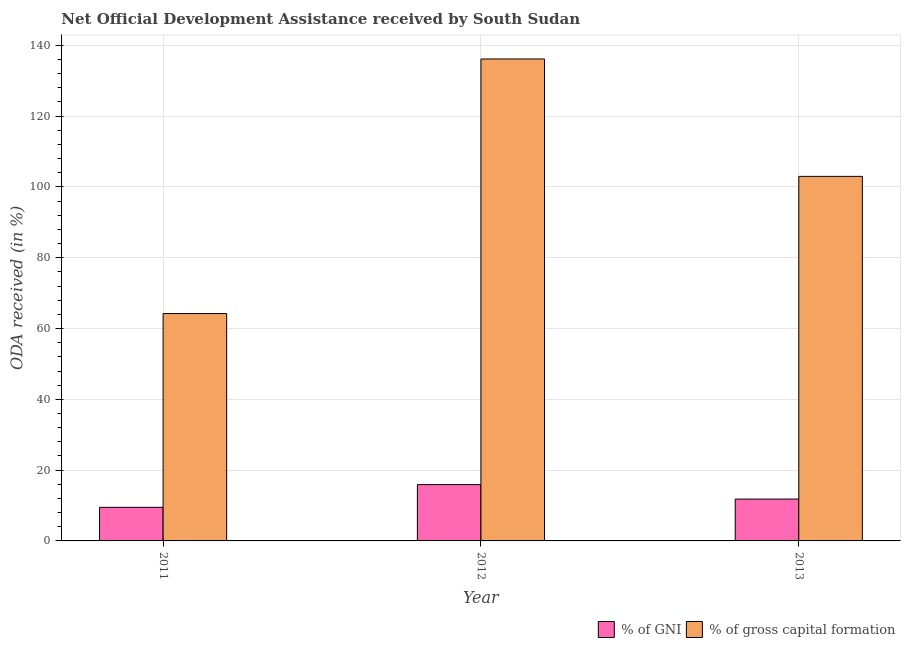How many different coloured bars are there?
Give a very brief answer. 2. How many groups of bars are there?
Ensure brevity in your answer.  3. Are the number of bars per tick equal to the number of legend labels?
Offer a terse response. Yes. How many bars are there on the 1st tick from the left?
Your answer should be very brief. 2. What is the label of the 3rd group of bars from the left?
Offer a terse response. 2013. What is the oda received as percentage of gni in 2011?
Your answer should be very brief. 9.49. Across all years, what is the maximum oda received as percentage of gross capital formation?
Give a very brief answer. 136.15. Across all years, what is the minimum oda received as percentage of gross capital formation?
Offer a terse response. 64.23. In which year was the oda received as percentage of gni minimum?
Make the answer very short. 2011. What is the total oda received as percentage of gross capital formation in the graph?
Give a very brief answer. 303.38. What is the difference between the oda received as percentage of gni in 2011 and that in 2013?
Your answer should be very brief. -2.34. What is the difference between the oda received as percentage of gni in 2012 and the oda received as percentage of gross capital formation in 2013?
Keep it short and to the point. 4.08. What is the average oda received as percentage of gross capital formation per year?
Provide a succinct answer. 101.13. In the year 2011, what is the difference between the oda received as percentage of gni and oda received as percentage of gross capital formation?
Offer a very short reply. 0. What is the ratio of the oda received as percentage of gni in 2011 to that in 2013?
Ensure brevity in your answer.  0.8. Is the oda received as percentage of gross capital formation in 2011 less than that in 2012?
Give a very brief answer. Yes. Is the difference between the oda received as percentage of gni in 2011 and 2012 greater than the difference between the oda received as percentage of gross capital formation in 2011 and 2012?
Offer a terse response. No. What is the difference between the highest and the second highest oda received as percentage of gni?
Provide a succinct answer. 4.08. What is the difference between the highest and the lowest oda received as percentage of gross capital formation?
Your response must be concise. 71.92. What does the 2nd bar from the left in 2013 represents?
Provide a succinct answer. % of gross capital formation. What does the 2nd bar from the right in 2012 represents?
Your response must be concise. % of GNI. How many bars are there?
Keep it short and to the point. 6. Are all the bars in the graph horizontal?
Ensure brevity in your answer.  No. How many years are there in the graph?
Give a very brief answer. 3. What is the difference between two consecutive major ticks on the Y-axis?
Your answer should be very brief. 20. Are the values on the major ticks of Y-axis written in scientific E-notation?
Provide a succinct answer. No. Does the graph contain any zero values?
Your response must be concise. No. Does the graph contain grids?
Your response must be concise. Yes. How many legend labels are there?
Your answer should be compact. 2. How are the legend labels stacked?
Give a very brief answer. Horizontal. What is the title of the graph?
Offer a very short reply. Net Official Development Assistance received by South Sudan. Does "Tetanus" appear as one of the legend labels in the graph?
Ensure brevity in your answer.  No. What is the label or title of the X-axis?
Your answer should be compact. Year. What is the label or title of the Y-axis?
Offer a very short reply. ODA received (in %). What is the ODA received (in %) in % of GNI in 2011?
Offer a very short reply. 9.49. What is the ODA received (in %) in % of gross capital formation in 2011?
Keep it short and to the point. 64.23. What is the ODA received (in %) of % of GNI in 2012?
Give a very brief answer. 15.9. What is the ODA received (in %) in % of gross capital formation in 2012?
Ensure brevity in your answer.  136.15. What is the ODA received (in %) in % of GNI in 2013?
Provide a succinct answer. 11.82. What is the ODA received (in %) of % of gross capital formation in 2013?
Your answer should be very brief. 102.99. Across all years, what is the maximum ODA received (in %) of % of GNI?
Give a very brief answer. 15.9. Across all years, what is the maximum ODA received (in %) in % of gross capital formation?
Provide a succinct answer. 136.15. Across all years, what is the minimum ODA received (in %) in % of GNI?
Offer a very short reply. 9.49. Across all years, what is the minimum ODA received (in %) of % of gross capital formation?
Your answer should be compact. 64.23. What is the total ODA received (in %) in % of GNI in the graph?
Provide a succinct answer. 37.21. What is the total ODA received (in %) of % of gross capital formation in the graph?
Make the answer very short. 303.38. What is the difference between the ODA received (in %) of % of GNI in 2011 and that in 2012?
Keep it short and to the point. -6.42. What is the difference between the ODA received (in %) in % of gross capital formation in 2011 and that in 2012?
Your answer should be compact. -71.92. What is the difference between the ODA received (in %) of % of GNI in 2011 and that in 2013?
Your answer should be very brief. -2.34. What is the difference between the ODA received (in %) in % of gross capital formation in 2011 and that in 2013?
Ensure brevity in your answer.  -38.76. What is the difference between the ODA received (in %) of % of GNI in 2012 and that in 2013?
Provide a succinct answer. 4.08. What is the difference between the ODA received (in %) of % of gross capital formation in 2012 and that in 2013?
Your response must be concise. 33.16. What is the difference between the ODA received (in %) in % of GNI in 2011 and the ODA received (in %) in % of gross capital formation in 2012?
Ensure brevity in your answer.  -126.67. What is the difference between the ODA received (in %) in % of GNI in 2011 and the ODA received (in %) in % of gross capital formation in 2013?
Offer a very short reply. -93.5. What is the difference between the ODA received (in %) of % of GNI in 2012 and the ODA received (in %) of % of gross capital formation in 2013?
Ensure brevity in your answer.  -87.09. What is the average ODA received (in %) of % of GNI per year?
Your answer should be very brief. 12.4. What is the average ODA received (in %) of % of gross capital formation per year?
Keep it short and to the point. 101.13. In the year 2011, what is the difference between the ODA received (in %) of % of GNI and ODA received (in %) of % of gross capital formation?
Give a very brief answer. -54.75. In the year 2012, what is the difference between the ODA received (in %) in % of GNI and ODA received (in %) in % of gross capital formation?
Keep it short and to the point. -120.25. In the year 2013, what is the difference between the ODA received (in %) in % of GNI and ODA received (in %) in % of gross capital formation?
Make the answer very short. -91.17. What is the ratio of the ODA received (in %) in % of GNI in 2011 to that in 2012?
Provide a short and direct response. 0.6. What is the ratio of the ODA received (in %) in % of gross capital formation in 2011 to that in 2012?
Make the answer very short. 0.47. What is the ratio of the ODA received (in %) of % of GNI in 2011 to that in 2013?
Ensure brevity in your answer.  0.8. What is the ratio of the ODA received (in %) of % of gross capital formation in 2011 to that in 2013?
Give a very brief answer. 0.62. What is the ratio of the ODA received (in %) in % of GNI in 2012 to that in 2013?
Make the answer very short. 1.35. What is the ratio of the ODA received (in %) in % of gross capital formation in 2012 to that in 2013?
Provide a short and direct response. 1.32. What is the difference between the highest and the second highest ODA received (in %) of % of GNI?
Offer a very short reply. 4.08. What is the difference between the highest and the second highest ODA received (in %) in % of gross capital formation?
Ensure brevity in your answer.  33.16. What is the difference between the highest and the lowest ODA received (in %) in % of GNI?
Keep it short and to the point. 6.42. What is the difference between the highest and the lowest ODA received (in %) of % of gross capital formation?
Give a very brief answer. 71.92. 